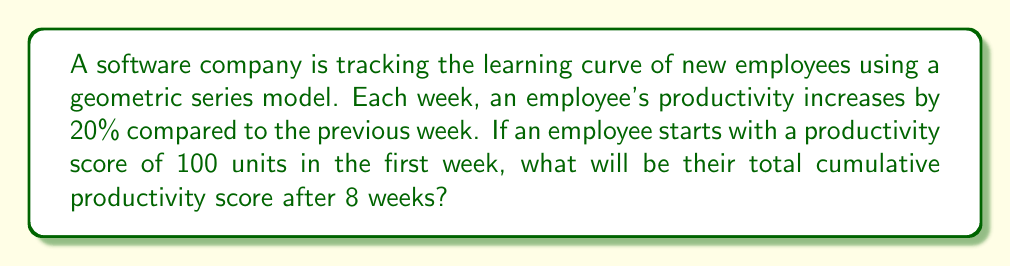Provide a solution to this math problem. Let's approach this step-by-step:

1) The geometric series for this scenario is:
   $$100 + 100(1.2) + 100(1.2)^2 + ... + 100(1.2)^7$$

2) This is a geometric series with:
   - First term $a = 100$
   - Common ratio $r = 1.2$
   - Number of terms $n = 8$

3) The formula for the sum of a geometric series is:
   $$S_n = \frac{a(1-r^n)}{1-r}, \text{ where } r \neq 1$$

4) Substituting our values:
   $$S_8 = \frac{100(1-1.2^8)}{1-1.2}$$

5) Calculate $1.2^8$:
   $$1.2^8 = 4.2998$$

6) Now our equation looks like:
   $$S_8 = \frac{100(1-4.2998)}{1-1.2} = \frac{100(-3.2998)}{-0.2}$$

7) Simplify:
   $$S_8 = \frac{329.98}{0.2} = 1649.9$$

8) Round to the nearest whole number:
   $$S_8 \approx 1650$$

Therefore, the total cumulative productivity score after 8 weeks is approximately 1650 units.
Answer: 1650 units 